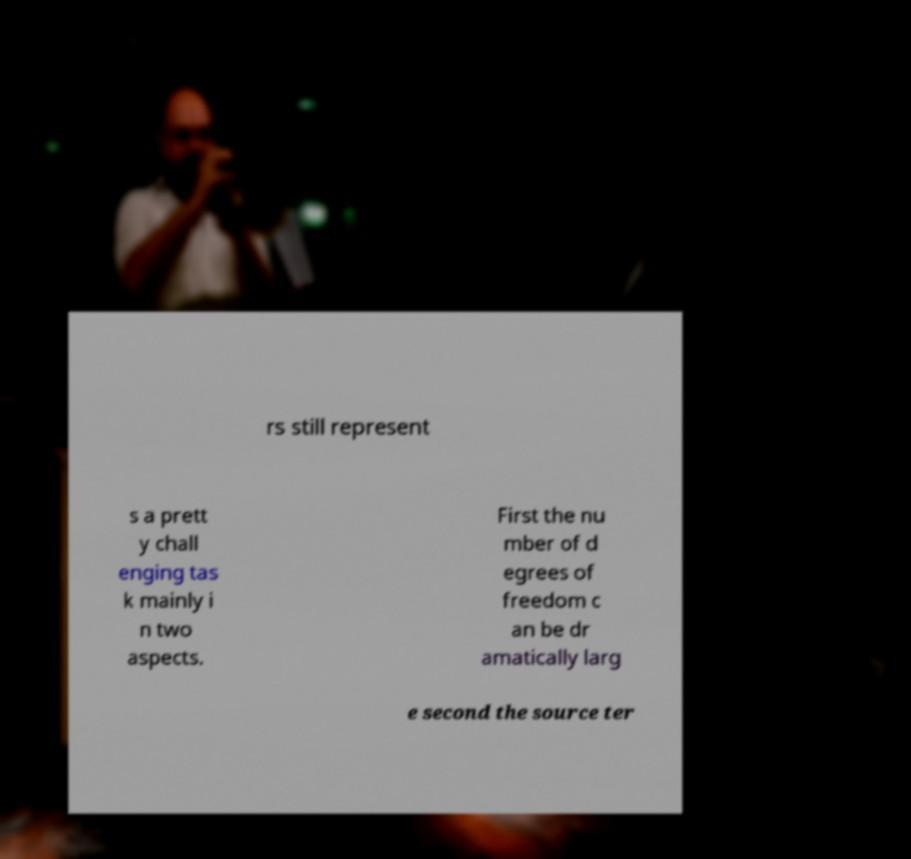Can you read and provide the text displayed in the image?This photo seems to have some interesting text. Can you extract and type it out for me? rs still represent s a prett y chall enging tas k mainly i n two aspects. First the nu mber of d egrees of freedom c an be dr amatically larg e second the source ter 